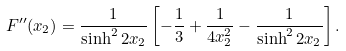<formula> <loc_0><loc_0><loc_500><loc_500>F ^ { \prime \prime } ( x _ { 2 } ) = \frac { 1 } { \sinh ^ { 2 } 2 x _ { 2 } } \left [ - \frac { 1 } { 3 } + \frac { 1 } { 4 x _ { 2 } ^ { 2 } } - \frac { 1 } { \sinh ^ { 2 } 2 x _ { 2 } } \right ] .</formula> 